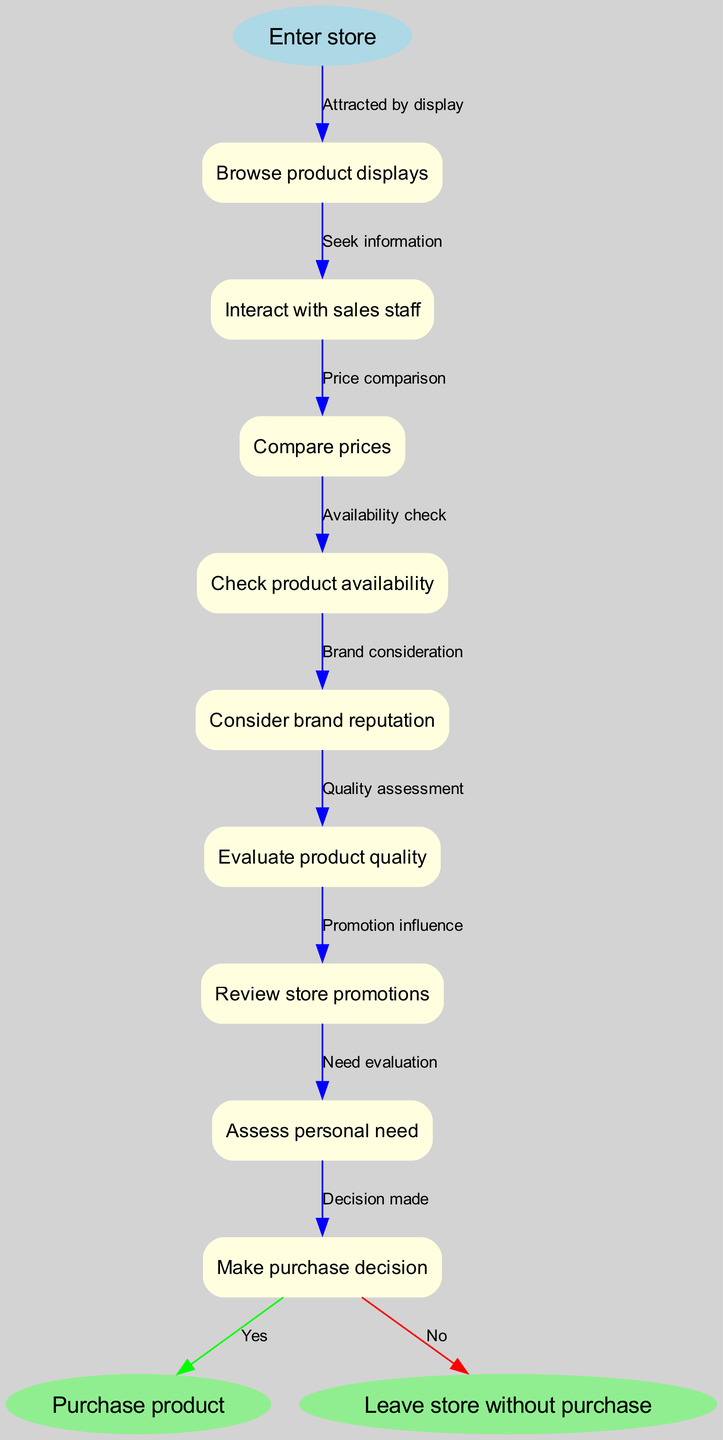What is the first step in the purchase decision process? The first step, as indicated in the diagram, is "Enter store." This is the starting point of the flowchart, which leads to the subsequent activities in the purchasing process.
Answer: Enter store How many nodes are there in total in the diagram? Counting the start node, intermediate nodes, and end nodes, there are a total of 10 nodes: 1 start, 8 intermediate, and 2 end nodes.
Answer: 10 What does the edge labeled "Price comparison" connect? The edge labeled "Price comparison" connects two nodes: it goes from "Compare prices" to "Check product availability." It symbolizes the flow from evaluating prices to checking if the product is available.
Answer: Compare prices to Check product availability Which node leads to the "Purchase product" end node? The node that leads to the "Purchase product" end node is "Make purchase decision." This indicates that after evaluating and deciding, the consumer can choose to purchase.
Answer: Make purchase decision What is the last step if the decision is "No"? If the decision is "No", the flow leads to the endpoint labeled "Leave store without purchase." This showcases the outcome when a customer decides not to buy.
Answer: Leave store without purchase Which two edges lead out of the "Make purchase decision" node? The "Make purchase decision" node has two edges leading out: one labeled "Yes" leading to "Purchase product" and one labeled "No" leading to "Leave store without purchase." This indicates the possible outcomes of the decision.
Answer: Yes and No What sequential steps lead to "Assess personal need"? The steps leading to "Assess personal need" are "Review store promotions," followed by "Evaluate product quality." This sequence implies that customers consider promotions, then evaluate quality before assessing their own needs.
Answer: Review store promotions and Evaluate product quality How many edges are there in the diagram? There are 9 edges in total. This includes connections from the start node through the intermediate nodes to both end nodes.
Answer: 9 Which nodes influence the decision-making process the most? The nodes that influence the decision-making process the most are "Consider brand reputation," "Evaluate product quality," and "Review store promotions." These nodes are critical as they directly affect the final purchase decision.
Answer: Consider brand reputation, Evaluate product quality, Review store promotions 